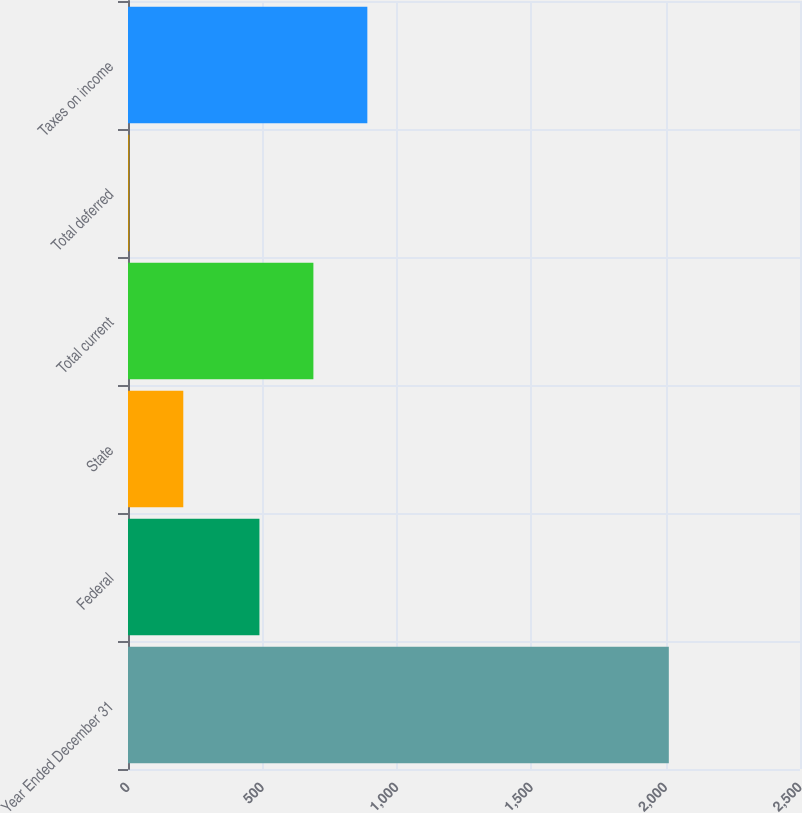<chart> <loc_0><loc_0><loc_500><loc_500><bar_chart><fcel>Year Ended December 31<fcel>Federal<fcel>State<fcel>Total current<fcel>Total deferred<fcel>Taxes on income<nl><fcel>2012<fcel>489<fcel>205.7<fcel>689.7<fcel>5<fcel>890.4<nl></chart> 